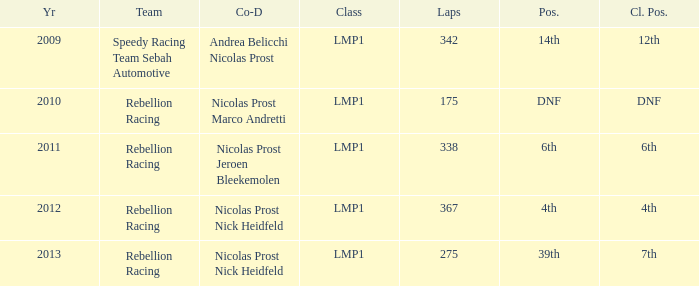What was the class position of the team that was in the 4th position? 4th. Give me the full table as a dictionary. {'header': ['Yr', 'Team', 'Co-D', 'Class', 'Laps', 'Pos.', 'Cl. Pos.'], 'rows': [['2009', 'Speedy Racing Team Sebah Automotive', 'Andrea Belicchi Nicolas Prost', 'LMP1', '342', '14th', '12th'], ['2010', 'Rebellion Racing', 'Nicolas Prost Marco Andretti', 'LMP1', '175', 'DNF', 'DNF'], ['2011', 'Rebellion Racing', 'Nicolas Prost Jeroen Bleekemolen', 'LMP1', '338', '6th', '6th'], ['2012', 'Rebellion Racing', 'Nicolas Prost Nick Heidfeld', 'LMP1', '367', '4th', '4th'], ['2013', 'Rebellion Racing', 'Nicolas Prost Nick Heidfeld', 'LMP1', '275', '39th', '7th']]} 